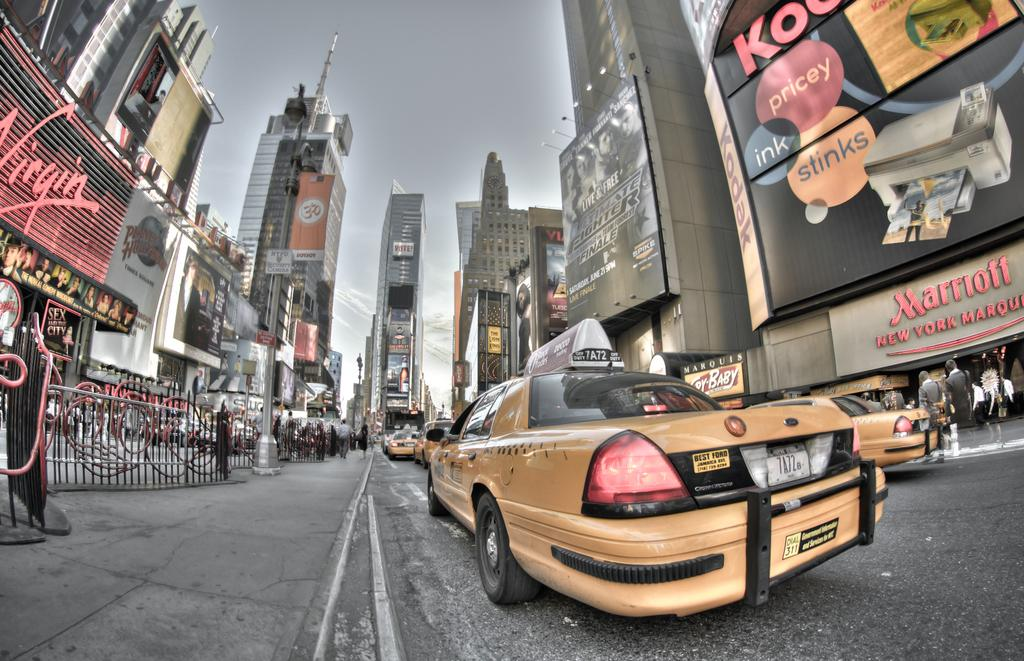<image>
Give a short and clear explanation of the subsequent image. A taxi rides on the sidewalk with a Virgin mobile sign near it 